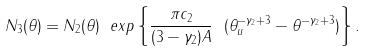Convert formula to latex. <formula><loc_0><loc_0><loc_500><loc_500>N _ { 3 } ( \theta ) = N _ { 2 } ( \theta ) \ e x p \left \{ \frac { \pi c _ { 2 } } { ( 3 - \gamma _ { 2 } ) A } \ ( \theta _ { u } ^ { - \gamma _ { 2 } + 3 } - \theta ^ { - \gamma _ { 2 } + 3 } ) \right \} .</formula> 